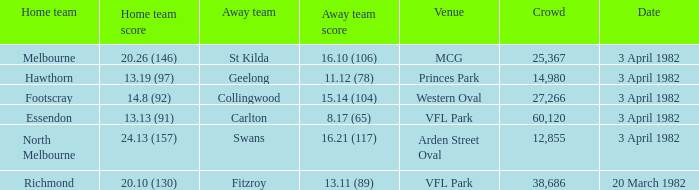What score did the home team of north melbourne get? 24.13 (157). 